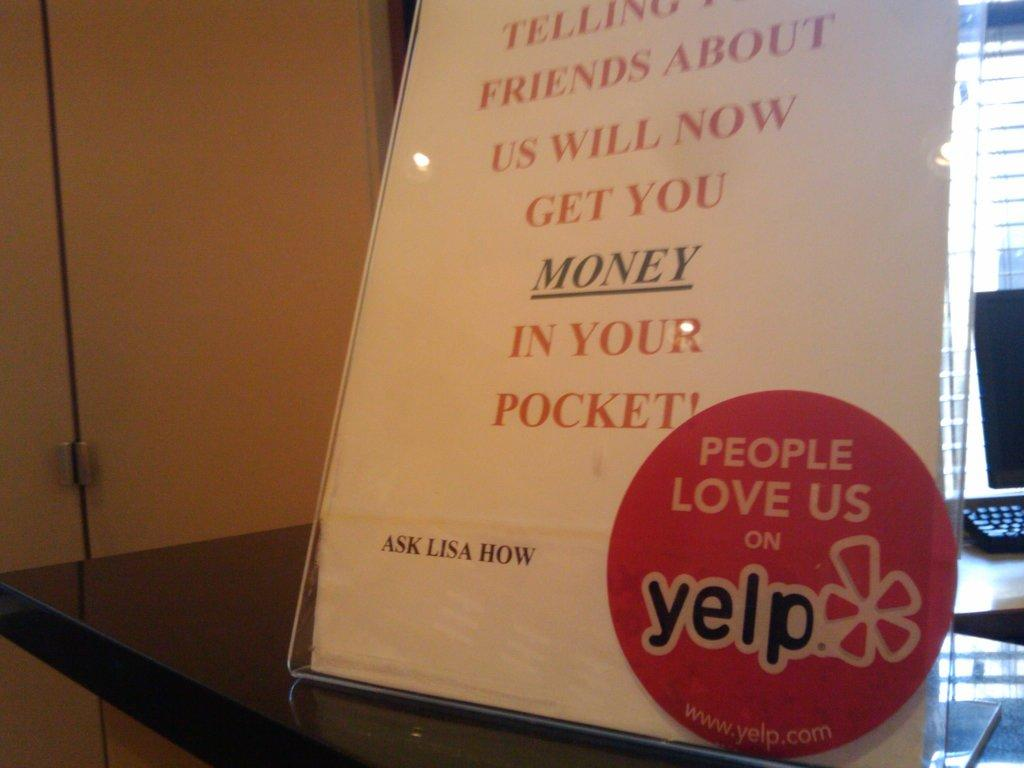<image>
Summarize the visual content of the image. A store sign lets customers know they can be paid for sharing a review on Yelp. 